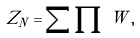Convert formula to latex. <formula><loc_0><loc_0><loc_500><loc_500>Z _ { N } = \sum \prod \, W \, ,</formula> 